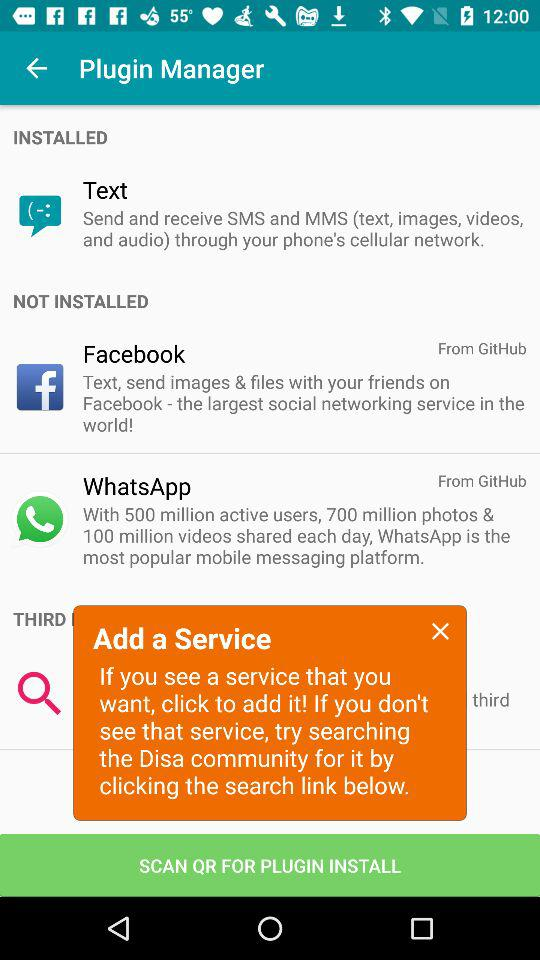How many plugins are not installed?
Answer the question using a single word or phrase. 2 